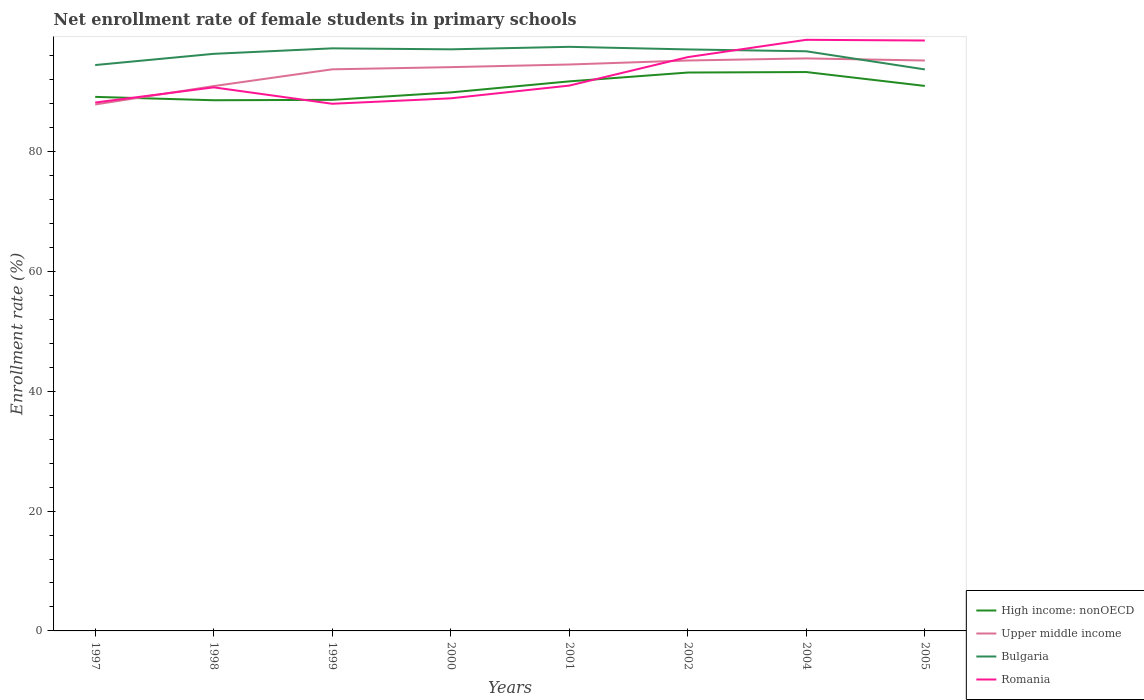Across all years, what is the maximum net enrollment rate of female students in primary schools in Romania?
Make the answer very short. 87.99. In which year was the net enrollment rate of female students in primary schools in Romania maximum?
Offer a very short reply. 1999. What is the total net enrollment rate of female students in primary schools in Upper middle income in the graph?
Provide a short and direct response. -0.67. What is the difference between the highest and the second highest net enrollment rate of female students in primary schools in Bulgaria?
Your answer should be compact. 3.77. What is the difference between the highest and the lowest net enrollment rate of female students in primary schools in Bulgaria?
Offer a terse response. 6. Is the net enrollment rate of female students in primary schools in Bulgaria strictly greater than the net enrollment rate of female students in primary schools in Upper middle income over the years?
Your answer should be very brief. No. What is the title of the graph?
Make the answer very short. Net enrollment rate of female students in primary schools. What is the label or title of the X-axis?
Provide a succinct answer. Years. What is the label or title of the Y-axis?
Provide a short and direct response. Enrollment rate (%). What is the Enrollment rate (%) of High income: nonOECD in 1997?
Your response must be concise. 89.15. What is the Enrollment rate (%) in Upper middle income in 1997?
Ensure brevity in your answer.  87.88. What is the Enrollment rate (%) in Bulgaria in 1997?
Provide a short and direct response. 94.46. What is the Enrollment rate (%) in Romania in 1997?
Offer a terse response. 88.2. What is the Enrollment rate (%) of High income: nonOECD in 1998?
Your answer should be very brief. 88.58. What is the Enrollment rate (%) of Upper middle income in 1998?
Give a very brief answer. 90.95. What is the Enrollment rate (%) in Bulgaria in 1998?
Make the answer very short. 96.33. What is the Enrollment rate (%) of Romania in 1998?
Your answer should be very brief. 90.73. What is the Enrollment rate (%) of High income: nonOECD in 1999?
Offer a terse response. 88.65. What is the Enrollment rate (%) in Upper middle income in 1999?
Provide a short and direct response. 93.74. What is the Enrollment rate (%) in Bulgaria in 1999?
Your answer should be very brief. 97.25. What is the Enrollment rate (%) of Romania in 1999?
Your answer should be compact. 87.99. What is the Enrollment rate (%) in High income: nonOECD in 2000?
Keep it short and to the point. 89.89. What is the Enrollment rate (%) in Upper middle income in 2000?
Your answer should be very brief. 94.11. What is the Enrollment rate (%) of Bulgaria in 2000?
Your answer should be compact. 97.08. What is the Enrollment rate (%) in Romania in 2000?
Make the answer very short. 88.9. What is the Enrollment rate (%) in High income: nonOECD in 2001?
Ensure brevity in your answer.  91.73. What is the Enrollment rate (%) in Upper middle income in 2001?
Offer a very short reply. 94.55. What is the Enrollment rate (%) in Bulgaria in 2001?
Your answer should be very brief. 97.5. What is the Enrollment rate (%) of Romania in 2001?
Your answer should be very brief. 91.03. What is the Enrollment rate (%) in High income: nonOECD in 2002?
Ensure brevity in your answer.  93.21. What is the Enrollment rate (%) of Upper middle income in 2002?
Ensure brevity in your answer.  95.22. What is the Enrollment rate (%) of Bulgaria in 2002?
Provide a succinct answer. 97.07. What is the Enrollment rate (%) in Romania in 2002?
Provide a short and direct response. 95.78. What is the Enrollment rate (%) in High income: nonOECD in 2004?
Your answer should be very brief. 93.29. What is the Enrollment rate (%) in Upper middle income in 2004?
Make the answer very short. 95.57. What is the Enrollment rate (%) in Bulgaria in 2004?
Make the answer very short. 96.76. What is the Enrollment rate (%) of Romania in 2004?
Offer a very short reply. 98.67. What is the Enrollment rate (%) in High income: nonOECD in 2005?
Give a very brief answer. 90.97. What is the Enrollment rate (%) of Upper middle income in 2005?
Ensure brevity in your answer.  95.22. What is the Enrollment rate (%) of Bulgaria in 2005?
Your answer should be very brief. 93.73. What is the Enrollment rate (%) in Romania in 2005?
Your answer should be compact. 98.55. Across all years, what is the maximum Enrollment rate (%) in High income: nonOECD?
Your answer should be very brief. 93.29. Across all years, what is the maximum Enrollment rate (%) of Upper middle income?
Your answer should be very brief. 95.57. Across all years, what is the maximum Enrollment rate (%) of Bulgaria?
Give a very brief answer. 97.5. Across all years, what is the maximum Enrollment rate (%) of Romania?
Keep it short and to the point. 98.67. Across all years, what is the minimum Enrollment rate (%) of High income: nonOECD?
Keep it short and to the point. 88.58. Across all years, what is the minimum Enrollment rate (%) in Upper middle income?
Provide a succinct answer. 87.88. Across all years, what is the minimum Enrollment rate (%) in Bulgaria?
Your answer should be very brief. 93.73. Across all years, what is the minimum Enrollment rate (%) of Romania?
Offer a terse response. 87.99. What is the total Enrollment rate (%) of High income: nonOECD in the graph?
Give a very brief answer. 725.48. What is the total Enrollment rate (%) of Upper middle income in the graph?
Your answer should be compact. 747.23. What is the total Enrollment rate (%) in Bulgaria in the graph?
Ensure brevity in your answer.  770.17. What is the total Enrollment rate (%) in Romania in the graph?
Offer a very short reply. 739.87. What is the difference between the Enrollment rate (%) of High income: nonOECD in 1997 and that in 1998?
Make the answer very short. 0.56. What is the difference between the Enrollment rate (%) in Upper middle income in 1997 and that in 1998?
Keep it short and to the point. -3.07. What is the difference between the Enrollment rate (%) in Bulgaria in 1997 and that in 1998?
Provide a succinct answer. -1.87. What is the difference between the Enrollment rate (%) in Romania in 1997 and that in 1998?
Provide a short and direct response. -2.53. What is the difference between the Enrollment rate (%) in High income: nonOECD in 1997 and that in 1999?
Offer a very short reply. 0.5. What is the difference between the Enrollment rate (%) of Upper middle income in 1997 and that in 1999?
Make the answer very short. -5.87. What is the difference between the Enrollment rate (%) in Bulgaria in 1997 and that in 1999?
Provide a short and direct response. -2.79. What is the difference between the Enrollment rate (%) of Romania in 1997 and that in 1999?
Provide a succinct answer. 0.21. What is the difference between the Enrollment rate (%) in High income: nonOECD in 1997 and that in 2000?
Offer a very short reply. -0.75. What is the difference between the Enrollment rate (%) of Upper middle income in 1997 and that in 2000?
Provide a succinct answer. -6.23. What is the difference between the Enrollment rate (%) in Bulgaria in 1997 and that in 2000?
Ensure brevity in your answer.  -2.62. What is the difference between the Enrollment rate (%) in Romania in 1997 and that in 2000?
Provide a short and direct response. -0.7. What is the difference between the Enrollment rate (%) of High income: nonOECD in 1997 and that in 2001?
Keep it short and to the point. -2.59. What is the difference between the Enrollment rate (%) of Upper middle income in 1997 and that in 2001?
Your response must be concise. -6.68. What is the difference between the Enrollment rate (%) of Bulgaria in 1997 and that in 2001?
Give a very brief answer. -3.04. What is the difference between the Enrollment rate (%) in Romania in 1997 and that in 2001?
Offer a very short reply. -2.83. What is the difference between the Enrollment rate (%) in High income: nonOECD in 1997 and that in 2002?
Ensure brevity in your answer.  -4.06. What is the difference between the Enrollment rate (%) in Upper middle income in 1997 and that in 2002?
Your answer should be very brief. -7.34. What is the difference between the Enrollment rate (%) in Bulgaria in 1997 and that in 2002?
Keep it short and to the point. -2.61. What is the difference between the Enrollment rate (%) of Romania in 1997 and that in 2002?
Your response must be concise. -7.58. What is the difference between the Enrollment rate (%) of High income: nonOECD in 1997 and that in 2004?
Make the answer very short. -4.14. What is the difference between the Enrollment rate (%) of Upper middle income in 1997 and that in 2004?
Provide a short and direct response. -7.69. What is the difference between the Enrollment rate (%) in Bulgaria in 1997 and that in 2004?
Give a very brief answer. -2.3. What is the difference between the Enrollment rate (%) of Romania in 1997 and that in 2004?
Your response must be concise. -10.47. What is the difference between the Enrollment rate (%) of High income: nonOECD in 1997 and that in 2005?
Your response must be concise. -1.83. What is the difference between the Enrollment rate (%) of Upper middle income in 1997 and that in 2005?
Offer a terse response. -7.34. What is the difference between the Enrollment rate (%) in Bulgaria in 1997 and that in 2005?
Provide a succinct answer. 0.73. What is the difference between the Enrollment rate (%) of Romania in 1997 and that in 2005?
Make the answer very short. -10.35. What is the difference between the Enrollment rate (%) of High income: nonOECD in 1998 and that in 1999?
Provide a succinct answer. -0.07. What is the difference between the Enrollment rate (%) in Upper middle income in 1998 and that in 1999?
Offer a very short reply. -2.8. What is the difference between the Enrollment rate (%) of Bulgaria in 1998 and that in 1999?
Ensure brevity in your answer.  -0.92. What is the difference between the Enrollment rate (%) of Romania in 1998 and that in 1999?
Your answer should be compact. 2.74. What is the difference between the Enrollment rate (%) of High income: nonOECD in 1998 and that in 2000?
Your response must be concise. -1.31. What is the difference between the Enrollment rate (%) of Upper middle income in 1998 and that in 2000?
Your answer should be compact. -3.16. What is the difference between the Enrollment rate (%) of Bulgaria in 1998 and that in 2000?
Keep it short and to the point. -0.75. What is the difference between the Enrollment rate (%) in Romania in 1998 and that in 2000?
Offer a terse response. 1.83. What is the difference between the Enrollment rate (%) in High income: nonOECD in 1998 and that in 2001?
Offer a very short reply. -3.15. What is the difference between the Enrollment rate (%) in Upper middle income in 1998 and that in 2001?
Your answer should be compact. -3.6. What is the difference between the Enrollment rate (%) of Bulgaria in 1998 and that in 2001?
Give a very brief answer. -1.17. What is the difference between the Enrollment rate (%) of Romania in 1998 and that in 2001?
Provide a short and direct response. -0.3. What is the difference between the Enrollment rate (%) of High income: nonOECD in 1998 and that in 2002?
Offer a terse response. -4.63. What is the difference between the Enrollment rate (%) in Upper middle income in 1998 and that in 2002?
Your answer should be very brief. -4.27. What is the difference between the Enrollment rate (%) of Bulgaria in 1998 and that in 2002?
Your answer should be very brief. -0.74. What is the difference between the Enrollment rate (%) of Romania in 1998 and that in 2002?
Give a very brief answer. -5.05. What is the difference between the Enrollment rate (%) of High income: nonOECD in 1998 and that in 2004?
Offer a very short reply. -4.71. What is the difference between the Enrollment rate (%) of Upper middle income in 1998 and that in 2004?
Your answer should be compact. -4.62. What is the difference between the Enrollment rate (%) of Bulgaria in 1998 and that in 2004?
Offer a very short reply. -0.42. What is the difference between the Enrollment rate (%) of Romania in 1998 and that in 2004?
Give a very brief answer. -7.94. What is the difference between the Enrollment rate (%) in High income: nonOECD in 1998 and that in 2005?
Offer a very short reply. -2.39. What is the difference between the Enrollment rate (%) in Upper middle income in 1998 and that in 2005?
Offer a very short reply. -4.27. What is the difference between the Enrollment rate (%) of Bulgaria in 1998 and that in 2005?
Provide a succinct answer. 2.6. What is the difference between the Enrollment rate (%) in Romania in 1998 and that in 2005?
Your response must be concise. -7.82. What is the difference between the Enrollment rate (%) in High income: nonOECD in 1999 and that in 2000?
Keep it short and to the point. -1.24. What is the difference between the Enrollment rate (%) in Upper middle income in 1999 and that in 2000?
Give a very brief answer. -0.37. What is the difference between the Enrollment rate (%) in Bulgaria in 1999 and that in 2000?
Provide a short and direct response. 0.16. What is the difference between the Enrollment rate (%) of Romania in 1999 and that in 2000?
Your answer should be compact. -0.91. What is the difference between the Enrollment rate (%) of High income: nonOECD in 1999 and that in 2001?
Provide a short and direct response. -3.08. What is the difference between the Enrollment rate (%) in Upper middle income in 1999 and that in 2001?
Offer a very short reply. -0.81. What is the difference between the Enrollment rate (%) in Bulgaria in 1999 and that in 2001?
Keep it short and to the point. -0.25. What is the difference between the Enrollment rate (%) in Romania in 1999 and that in 2001?
Provide a short and direct response. -3.04. What is the difference between the Enrollment rate (%) of High income: nonOECD in 1999 and that in 2002?
Provide a succinct answer. -4.56. What is the difference between the Enrollment rate (%) of Upper middle income in 1999 and that in 2002?
Your answer should be very brief. -1.47. What is the difference between the Enrollment rate (%) of Bulgaria in 1999 and that in 2002?
Give a very brief answer. 0.18. What is the difference between the Enrollment rate (%) in Romania in 1999 and that in 2002?
Make the answer very short. -7.79. What is the difference between the Enrollment rate (%) in High income: nonOECD in 1999 and that in 2004?
Make the answer very short. -4.64. What is the difference between the Enrollment rate (%) in Upper middle income in 1999 and that in 2004?
Ensure brevity in your answer.  -1.82. What is the difference between the Enrollment rate (%) in Bulgaria in 1999 and that in 2004?
Your response must be concise. 0.49. What is the difference between the Enrollment rate (%) in Romania in 1999 and that in 2004?
Keep it short and to the point. -10.68. What is the difference between the Enrollment rate (%) of High income: nonOECD in 1999 and that in 2005?
Provide a succinct answer. -2.32. What is the difference between the Enrollment rate (%) of Upper middle income in 1999 and that in 2005?
Your answer should be compact. -1.47. What is the difference between the Enrollment rate (%) in Bulgaria in 1999 and that in 2005?
Provide a succinct answer. 3.52. What is the difference between the Enrollment rate (%) of Romania in 1999 and that in 2005?
Give a very brief answer. -10.56. What is the difference between the Enrollment rate (%) in High income: nonOECD in 2000 and that in 2001?
Offer a terse response. -1.84. What is the difference between the Enrollment rate (%) of Upper middle income in 2000 and that in 2001?
Offer a very short reply. -0.44. What is the difference between the Enrollment rate (%) in Bulgaria in 2000 and that in 2001?
Your response must be concise. -0.42. What is the difference between the Enrollment rate (%) in Romania in 2000 and that in 2001?
Your answer should be compact. -2.13. What is the difference between the Enrollment rate (%) in High income: nonOECD in 2000 and that in 2002?
Your response must be concise. -3.32. What is the difference between the Enrollment rate (%) in Upper middle income in 2000 and that in 2002?
Provide a short and direct response. -1.11. What is the difference between the Enrollment rate (%) in Bulgaria in 2000 and that in 2002?
Provide a short and direct response. 0.02. What is the difference between the Enrollment rate (%) of Romania in 2000 and that in 2002?
Offer a very short reply. -6.88. What is the difference between the Enrollment rate (%) of High income: nonOECD in 2000 and that in 2004?
Ensure brevity in your answer.  -3.4. What is the difference between the Enrollment rate (%) of Upper middle income in 2000 and that in 2004?
Provide a succinct answer. -1.46. What is the difference between the Enrollment rate (%) in Bulgaria in 2000 and that in 2004?
Make the answer very short. 0.33. What is the difference between the Enrollment rate (%) in Romania in 2000 and that in 2004?
Ensure brevity in your answer.  -9.77. What is the difference between the Enrollment rate (%) of High income: nonOECD in 2000 and that in 2005?
Provide a short and direct response. -1.08. What is the difference between the Enrollment rate (%) of Upper middle income in 2000 and that in 2005?
Your answer should be compact. -1.11. What is the difference between the Enrollment rate (%) in Bulgaria in 2000 and that in 2005?
Your answer should be compact. 3.35. What is the difference between the Enrollment rate (%) of Romania in 2000 and that in 2005?
Offer a terse response. -9.65. What is the difference between the Enrollment rate (%) of High income: nonOECD in 2001 and that in 2002?
Give a very brief answer. -1.47. What is the difference between the Enrollment rate (%) in Upper middle income in 2001 and that in 2002?
Offer a very short reply. -0.67. What is the difference between the Enrollment rate (%) of Bulgaria in 2001 and that in 2002?
Provide a succinct answer. 0.43. What is the difference between the Enrollment rate (%) in Romania in 2001 and that in 2002?
Give a very brief answer. -4.75. What is the difference between the Enrollment rate (%) of High income: nonOECD in 2001 and that in 2004?
Offer a terse response. -1.55. What is the difference between the Enrollment rate (%) in Upper middle income in 2001 and that in 2004?
Provide a succinct answer. -1.02. What is the difference between the Enrollment rate (%) of Bulgaria in 2001 and that in 2004?
Make the answer very short. 0.74. What is the difference between the Enrollment rate (%) in Romania in 2001 and that in 2004?
Offer a terse response. -7.64. What is the difference between the Enrollment rate (%) in High income: nonOECD in 2001 and that in 2005?
Provide a short and direct response. 0.76. What is the difference between the Enrollment rate (%) in Upper middle income in 2001 and that in 2005?
Your response must be concise. -0.67. What is the difference between the Enrollment rate (%) in Bulgaria in 2001 and that in 2005?
Your answer should be very brief. 3.77. What is the difference between the Enrollment rate (%) of Romania in 2001 and that in 2005?
Offer a very short reply. -7.52. What is the difference between the Enrollment rate (%) in High income: nonOECD in 2002 and that in 2004?
Offer a very short reply. -0.08. What is the difference between the Enrollment rate (%) in Upper middle income in 2002 and that in 2004?
Offer a very short reply. -0.35. What is the difference between the Enrollment rate (%) in Bulgaria in 2002 and that in 2004?
Keep it short and to the point. 0.31. What is the difference between the Enrollment rate (%) in Romania in 2002 and that in 2004?
Keep it short and to the point. -2.89. What is the difference between the Enrollment rate (%) in High income: nonOECD in 2002 and that in 2005?
Your answer should be compact. 2.24. What is the difference between the Enrollment rate (%) in Upper middle income in 2002 and that in 2005?
Your answer should be very brief. -0. What is the difference between the Enrollment rate (%) in Bulgaria in 2002 and that in 2005?
Offer a terse response. 3.34. What is the difference between the Enrollment rate (%) of Romania in 2002 and that in 2005?
Give a very brief answer. -2.77. What is the difference between the Enrollment rate (%) of High income: nonOECD in 2004 and that in 2005?
Your answer should be very brief. 2.32. What is the difference between the Enrollment rate (%) of Upper middle income in 2004 and that in 2005?
Keep it short and to the point. 0.35. What is the difference between the Enrollment rate (%) of Bulgaria in 2004 and that in 2005?
Keep it short and to the point. 3.03. What is the difference between the Enrollment rate (%) of Romania in 2004 and that in 2005?
Make the answer very short. 0.12. What is the difference between the Enrollment rate (%) in High income: nonOECD in 1997 and the Enrollment rate (%) in Upper middle income in 1998?
Provide a short and direct response. -1.8. What is the difference between the Enrollment rate (%) of High income: nonOECD in 1997 and the Enrollment rate (%) of Bulgaria in 1998?
Your response must be concise. -7.18. What is the difference between the Enrollment rate (%) in High income: nonOECD in 1997 and the Enrollment rate (%) in Romania in 1998?
Offer a very short reply. -1.59. What is the difference between the Enrollment rate (%) in Upper middle income in 1997 and the Enrollment rate (%) in Bulgaria in 1998?
Your response must be concise. -8.46. What is the difference between the Enrollment rate (%) of Upper middle income in 1997 and the Enrollment rate (%) of Romania in 1998?
Your answer should be compact. -2.86. What is the difference between the Enrollment rate (%) in Bulgaria in 1997 and the Enrollment rate (%) in Romania in 1998?
Give a very brief answer. 3.72. What is the difference between the Enrollment rate (%) of High income: nonOECD in 1997 and the Enrollment rate (%) of Upper middle income in 1999?
Make the answer very short. -4.6. What is the difference between the Enrollment rate (%) in High income: nonOECD in 1997 and the Enrollment rate (%) in Bulgaria in 1999?
Ensure brevity in your answer.  -8.1. What is the difference between the Enrollment rate (%) of High income: nonOECD in 1997 and the Enrollment rate (%) of Romania in 1999?
Offer a terse response. 1.15. What is the difference between the Enrollment rate (%) of Upper middle income in 1997 and the Enrollment rate (%) of Bulgaria in 1999?
Offer a very short reply. -9.37. What is the difference between the Enrollment rate (%) in Upper middle income in 1997 and the Enrollment rate (%) in Romania in 1999?
Your answer should be compact. -0.12. What is the difference between the Enrollment rate (%) in Bulgaria in 1997 and the Enrollment rate (%) in Romania in 1999?
Give a very brief answer. 6.46. What is the difference between the Enrollment rate (%) in High income: nonOECD in 1997 and the Enrollment rate (%) in Upper middle income in 2000?
Make the answer very short. -4.96. What is the difference between the Enrollment rate (%) in High income: nonOECD in 1997 and the Enrollment rate (%) in Bulgaria in 2000?
Offer a very short reply. -7.94. What is the difference between the Enrollment rate (%) in High income: nonOECD in 1997 and the Enrollment rate (%) in Romania in 2000?
Keep it short and to the point. 0.24. What is the difference between the Enrollment rate (%) of Upper middle income in 1997 and the Enrollment rate (%) of Bulgaria in 2000?
Your response must be concise. -9.21. What is the difference between the Enrollment rate (%) in Upper middle income in 1997 and the Enrollment rate (%) in Romania in 2000?
Provide a short and direct response. -1.03. What is the difference between the Enrollment rate (%) of Bulgaria in 1997 and the Enrollment rate (%) of Romania in 2000?
Provide a succinct answer. 5.56. What is the difference between the Enrollment rate (%) in High income: nonOECD in 1997 and the Enrollment rate (%) in Upper middle income in 2001?
Give a very brief answer. -5.4. What is the difference between the Enrollment rate (%) of High income: nonOECD in 1997 and the Enrollment rate (%) of Bulgaria in 2001?
Offer a very short reply. -8.35. What is the difference between the Enrollment rate (%) of High income: nonOECD in 1997 and the Enrollment rate (%) of Romania in 2001?
Your answer should be very brief. -1.88. What is the difference between the Enrollment rate (%) of Upper middle income in 1997 and the Enrollment rate (%) of Bulgaria in 2001?
Ensure brevity in your answer.  -9.62. What is the difference between the Enrollment rate (%) of Upper middle income in 1997 and the Enrollment rate (%) of Romania in 2001?
Your answer should be compact. -3.16. What is the difference between the Enrollment rate (%) in Bulgaria in 1997 and the Enrollment rate (%) in Romania in 2001?
Offer a terse response. 3.43. What is the difference between the Enrollment rate (%) in High income: nonOECD in 1997 and the Enrollment rate (%) in Upper middle income in 2002?
Give a very brief answer. -6.07. What is the difference between the Enrollment rate (%) in High income: nonOECD in 1997 and the Enrollment rate (%) in Bulgaria in 2002?
Make the answer very short. -7.92. What is the difference between the Enrollment rate (%) in High income: nonOECD in 1997 and the Enrollment rate (%) in Romania in 2002?
Your answer should be very brief. -6.64. What is the difference between the Enrollment rate (%) of Upper middle income in 1997 and the Enrollment rate (%) of Bulgaria in 2002?
Keep it short and to the point. -9.19. What is the difference between the Enrollment rate (%) of Upper middle income in 1997 and the Enrollment rate (%) of Romania in 2002?
Ensure brevity in your answer.  -7.91. What is the difference between the Enrollment rate (%) of Bulgaria in 1997 and the Enrollment rate (%) of Romania in 2002?
Your answer should be very brief. -1.32. What is the difference between the Enrollment rate (%) of High income: nonOECD in 1997 and the Enrollment rate (%) of Upper middle income in 2004?
Ensure brevity in your answer.  -6.42. What is the difference between the Enrollment rate (%) in High income: nonOECD in 1997 and the Enrollment rate (%) in Bulgaria in 2004?
Your response must be concise. -7.61. What is the difference between the Enrollment rate (%) of High income: nonOECD in 1997 and the Enrollment rate (%) of Romania in 2004?
Your answer should be very brief. -9.52. What is the difference between the Enrollment rate (%) of Upper middle income in 1997 and the Enrollment rate (%) of Bulgaria in 2004?
Offer a very short reply. -8.88. What is the difference between the Enrollment rate (%) of Upper middle income in 1997 and the Enrollment rate (%) of Romania in 2004?
Keep it short and to the point. -10.8. What is the difference between the Enrollment rate (%) in Bulgaria in 1997 and the Enrollment rate (%) in Romania in 2004?
Offer a very short reply. -4.21. What is the difference between the Enrollment rate (%) in High income: nonOECD in 1997 and the Enrollment rate (%) in Upper middle income in 2005?
Your answer should be very brief. -6.07. What is the difference between the Enrollment rate (%) of High income: nonOECD in 1997 and the Enrollment rate (%) of Bulgaria in 2005?
Make the answer very short. -4.58. What is the difference between the Enrollment rate (%) of High income: nonOECD in 1997 and the Enrollment rate (%) of Romania in 2005?
Offer a very short reply. -9.41. What is the difference between the Enrollment rate (%) of Upper middle income in 1997 and the Enrollment rate (%) of Bulgaria in 2005?
Your answer should be compact. -5.85. What is the difference between the Enrollment rate (%) in Upper middle income in 1997 and the Enrollment rate (%) in Romania in 2005?
Give a very brief answer. -10.68. What is the difference between the Enrollment rate (%) in Bulgaria in 1997 and the Enrollment rate (%) in Romania in 2005?
Keep it short and to the point. -4.1. What is the difference between the Enrollment rate (%) in High income: nonOECD in 1998 and the Enrollment rate (%) in Upper middle income in 1999?
Your response must be concise. -5.16. What is the difference between the Enrollment rate (%) of High income: nonOECD in 1998 and the Enrollment rate (%) of Bulgaria in 1999?
Keep it short and to the point. -8.66. What is the difference between the Enrollment rate (%) of High income: nonOECD in 1998 and the Enrollment rate (%) of Romania in 1999?
Make the answer very short. 0.59. What is the difference between the Enrollment rate (%) of Upper middle income in 1998 and the Enrollment rate (%) of Bulgaria in 1999?
Make the answer very short. -6.3. What is the difference between the Enrollment rate (%) of Upper middle income in 1998 and the Enrollment rate (%) of Romania in 1999?
Offer a terse response. 2.95. What is the difference between the Enrollment rate (%) of Bulgaria in 1998 and the Enrollment rate (%) of Romania in 1999?
Make the answer very short. 8.34. What is the difference between the Enrollment rate (%) of High income: nonOECD in 1998 and the Enrollment rate (%) of Upper middle income in 2000?
Your response must be concise. -5.53. What is the difference between the Enrollment rate (%) of High income: nonOECD in 1998 and the Enrollment rate (%) of Bulgaria in 2000?
Your answer should be very brief. -8.5. What is the difference between the Enrollment rate (%) of High income: nonOECD in 1998 and the Enrollment rate (%) of Romania in 2000?
Ensure brevity in your answer.  -0.32. What is the difference between the Enrollment rate (%) of Upper middle income in 1998 and the Enrollment rate (%) of Bulgaria in 2000?
Offer a very short reply. -6.14. What is the difference between the Enrollment rate (%) of Upper middle income in 1998 and the Enrollment rate (%) of Romania in 2000?
Give a very brief answer. 2.04. What is the difference between the Enrollment rate (%) of Bulgaria in 1998 and the Enrollment rate (%) of Romania in 2000?
Offer a terse response. 7.43. What is the difference between the Enrollment rate (%) of High income: nonOECD in 1998 and the Enrollment rate (%) of Upper middle income in 2001?
Give a very brief answer. -5.97. What is the difference between the Enrollment rate (%) in High income: nonOECD in 1998 and the Enrollment rate (%) in Bulgaria in 2001?
Ensure brevity in your answer.  -8.92. What is the difference between the Enrollment rate (%) in High income: nonOECD in 1998 and the Enrollment rate (%) in Romania in 2001?
Offer a very short reply. -2.45. What is the difference between the Enrollment rate (%) in Upper middle income in 1998 and the Enrollment rate (%) in Bulgaria in 2001?
Your response must be concise. -6.55. What is the difference between the Enrollment rate (%) of Upper middle income in 1998 and the Enrollment rate (%) of Romania in 2001?
Offer a very short reply. -0.09. What is the difference between the Enrollment rate (%) in Bulgaria in 1998 and the Enrollment rate (%) in Romania in 2001?
Give a very brief answer. 5.3. What is the difference between the Enrollment rate (%) of High income: nonOECD in 1998 and the Enrollment rate (%) of Upper middle income in 2002?
Keep it short and to the point. -6.63. What is the difference between the Enrollment rate (%) of High income: nonOECD in 1998 and the Enrollment rate (%) of Bulgaria in 2002?
Provide a succinct answer. -8.48. What is the difference between the Enrollment rate (%) of High income: nonOECD in 1998 and the Enrollment rate (%) of Romania in 2002?
Provide a short and direct response. -7.2. What is the difference between the Enrollment rate (%) in Upper middle income in 1998 and the Enrollment rate (%) in Bulgaria in 2002?
Your response must be concise. -6.12. What is the difference between the Enrollment rate (%) of Upper middle income in 1998 and the Enrollment rate (%) of Romania in 2002?
Ensure brevity in your answer.  -4.84. What is the difference between the Enrollment rate (%) in Bulgaria in 1998 and the Enrollment rate (%) in Romania in 2002?
Keep it short and to the point. 0.55. What is the difference between the Enrollment rate (%) of High income: nonOECD in 1998 and the Enrollment rate (%) of Upper middle income in 2004?
Your answer should be very brief. -6.98. What is the difference between the Enrollment rate (%) of High income: nonOECD in 1998 and the Enrollment rate (%) of Bulgaria in 2004?
Keep it short and to the point. -8.17. What is the difference between the Enrollment rate (%) in High income: nonOECD in 1998 and the Enrollment rate (%) in Romania in 2004?
Make the answer very short. -10.09. What is the difference between the Enrollment rate (%) of Upper middle income in 1998 and the Enrollment rate (%) of Bulgaria in 2004?
Make the answer very short. -5.81. What is the difference between the Enrollment rate (%) in Upper middle income in 1998 and the Enrollment rate (%) in Romania in 2004?
Offer a very short reply. -7.73. What is the difference between the Enrollment rate (%) in Bulgaria in 1998 and the Enrollment rate (%) in Romania in 2004?
Make the answer very short. -2.34. What is the difference between the Enrollment rate (%) in High income: nonOECD in 1998 and the Enrollment rate (%) in Upper middle income in 2005?
Provide a short and direct response. -6.64. What is the difference between the Enrollment rate (%) in High income: nonOECD in 1998 and the Enrollment rate (%) in Bulgaria in 2005?
Give a very brief answer. -5.15. What is the difference between the Enrollment rate (%) in High income: nonOECD in 1998 and the Enrollment rate (%) in Romania in 2005?
Your response must be concise. -9.97. What is the difference between the Enrollment rate (%) of Upper middle income in 1998 and the Enrollment rate (%) of Bulgaria in 2005?
Ensure brevity in your answer.  -2.78. What is the difference between the Enrollment rate (%) in Upper middle income in 1998 and the Enrollment rate (%) in Romania in 2005?
Provide a short and direct response. -7.61. What is the difference between the Enrollment rate (%) in Bulgaria in 1998 and the Enrollment rate (%) in Romania in 2005?
Make the answer very short. -2.22. What is the difference between the Enrollment rate (%) in High income: nonOECD in 1999 and the Enrollment rate (%) in Upper middle income in 2000?
Provide a short and direct response. -5.46. What is the difference between the Enrollment rate (%) of High income: nonOECD in 1999 and the Enrollment rate (%) of Bulgaria in 2000?
Provide a short and direct response. -8.43. What is the difference between the Enrollment rate (%) in High income: nonOECD in 1999 and the Enrollment rate (%) in Romania in 2000?
Ensure brevity in your answer.  -0.25. What is the difference between the Enrollment rate (%) in Upper middle income in 1999 and the Enrollment rate (%) in Bulgaria in 2000?
Keep it short and to the point. -3.34. What is the difference between the Enrollment rate (%) in Upper middle income in 1999 and the Enrollment rate (%) in Romania in 2000?
Provide a succinct answer. 4.84. What is the difference between the Enrollment rate (%) in Bulgaria in 1999 and the Enrollment rate (%) in Romania in 2000?
Provide a short and direct response. 8.34. What is the difference between the Enrollment rate (%) of High income: nonOECD in 1999 and the Enrollment rate (%) of Upper middle income in 2001?
Keep it short and to the point. -5.9. What is the difference between the Enrollment rate (%) of High income: nonOECD in 1999 and the Enrollment rate (%) of Bulgaria in 2001?
Offer a terse response. -8.85. What is the difference between the Enrollment rate (%) of High income: nonOECD in 1999 and the Enrollment rate (%) of Romania in 2001?
Provide a short and direct response. -2.38. What is the difference between the Enrollment rate (%) in Upper middle income in 1999 and the Enrollment rate (%) in Bulgaria in 2001?
Offer a very short reply. -3.75. What is the difference between the Enrollment rate (%) in Upper middle income in 1999 and the Enrollment rate (%) in Romania in 2001?
Your answer should be very brief. 2.71. What is the difference between the Enrollment rate (%) of Bulgaria in 1999 and the Enrollment rate (%) of Romania in 2001?
Provide a short and direct response. 6.22. What is the difference between the Enrollment rate (%) in High income: nonOECD in 1999 and the Enrollment rate (%) in Upper middle income in 2002?
Your answer should be compact. -6.57. What is the difference between the Enrollment rate (%) in High income: nonOECD in 1999 and the Enrollment rate (%) in Bulgaria in 2002?
Your response must be concise. -8.42. What is the difference between the Enrollment rate (%) of High income: nonOECD in 1999 and the Enrollment rate (%) of Romania in 2002?
Your response must be concise. -7.13. What is the difference between the Enrollment rate (%) in Upper middle income in 1999 and the Enrollment rate (%) in Bulgaria in 2002?
Your answer should be very brief. -3.32. What is the difference between the Enrollment rate (%) in Upper middle income in 1999 and the Enrollment rate (%) in Romania in 2002?
Provide a short and direct response. -2.04. What is the difference between the Enrollment rate (%) in Bulgaria in 1999 and the Enrollment rate (%) in Romania in 2002?
Make the answer very short. 1.46. What is the difference between the Enrollment rate (%) of High income: nonOECD in 1999 and the Enrollment rate (%) of Upper middle income in 2004?
Your response must be concise. -6.92. What is the difference between the Enrollment rate (%) in High income: nonOECD in 1999 and the Enrollment rate (%) in Bulgaria in 2004?
Offer a very short reply. -8.1. What is the difference between the Enrollment rate (%) in High income: nonOECD in 1999 and the Enrollment rate (%) in Romania in 2004?
Give a very brief answer. -10.02. What is the difference between the Enrollment rate (%) of Upper middle income in 1999 and the Enrollment rate (%) of Bulgaria in 2004?
Your answer should be compact. -3.01. What is the difference between the Enrollment rate (%) in Upper middle income in 1999 and the Enrollment rate (%) in Romania in 2004?
Provide a succinct answer. -4.93. What is the difference between the Enrollment rate (%) in Bulgaria in 1999 and the Enrollment rate (%) in Romania in 2004?
Offer a very short reply. -1.42. What is the difference between the Enrollment rate (%) in High income: nonOECD in 1999 and the Enrollment rate (%) in Upper middle income in 2005?
Give a very brief answer. -6.57. What is the difference between the Enrollment rate (%) in High income: nonOECD in 1999 and the Enrollment rate (%) in Bulgaria in 2005?
Ensure brevity in your answer.  -5.08. What is the difference between the Enrollment rate (%) in High income: nonOECD in 1999 and the Enrollment rate (%) in Romania in 2005?
Ensure brevity in your answer.  -9.9. What is the difference between the Enrollment rate (%) in Upper middle income in 1999 and the Enrollment rate (%) in Bulgaria in 2005?
Your answer should be very brief. 0.02. What is the difference between the Enrollment rate (%) of Upper middle income in 1999 and the Enrollment rate (%) of Romania in 2005?
Offer a terse response. -4.81. What is the difference between the Enrollment rate (%) of Bulgaria in 1999 and the Enrollment rate (%) of Romania in 2005?
Your answer should be very brief. -1.31. What is the difference between the Enrollment rate (%) in High income: nonOECD in 2000 and the Enrollment rate (%) in Upper middle income in 2001?
Ensure brevity in your answer.  -4.66. What is the difference between the Enrollment rate (%) of High income: nonOECD in 2000 and the Enrollment rate (%) of Bulgaria in 2001?
Give a very brief answer. -7.61. What is the difference between the Enrollment rate (%) in High income: nonOECD in 2000 and the Enrollment rate (%) in Romania in 2001?
Give a very brief answer. -1.14. What is the difference between the Enrollment rate (%) in Upper middle income in 2000 and the Enrollment rate (%) in Bulgaria in 2001?
Provide a succinct answer. -3.39. What is the difference between the Enrollment rate (%) in Upper middle income in 2000 and the Enrollment rate (%) in Romania in 2001?
Provide a short and direct response. 3.08. What is the difference between the Enrollment rate (%) of Bulgaria in 2000 and the Enrollment rate (%) of Romania in 2001?
Provide a short and direct response. 6.05. What is the difference between the Enrollment rate (%) of High income: nonOECD in 2000 and the Enrollment rate (%) of Upper middle income in 2002?
Keep it short and to the point. -5.32. What is the difference between the Enrollment rate (%) of High income: nonOECD in 2000 and the Enrollment rate (%) of Bulgaria in 2002?
Ensure brevity in your answer.  -7.18. What is the difference between the Enrollment rate (%) in High income: nonOECD in 2000 and the Enrollment rate (%) in Romania in 2002?
Your answer should be very brief. -5.89. What is the difference between the Enrollment rate (%) in Upper middle income in 2000 and the Enrollment rate (%) in Bulgaria in 2002?
Ensure brevity in your answer.  -2.96. What is the difference between the Enrollment rate (%) of Upper middle income in 2000 and the Enrollment rate (%) of Romania in 2002?
Offer a very short reply. -1.67. What is the difference between the Enrollment rate (%) of Bulgaria in 2000 and the Enrollment rate (%) of Romania in 2002?
Make the answer very short. 1.3. What is the difference between the Enrollment rate (%) in High income: nonOECD in 2000 and the Enrollment rate (%) in Upper middle income in 2004?
Make the answer very short. -5.67. What is the difference between the Enrollment rate (%) of High income: nonOECD in 2000 and the Enrollment rate (%) of Bulgaria in 2004?
Give a very brief answer. -6.86. What is the difference between the Enrollment rate (%) in High income: nonOECD in 2000 and the Enrollment rate (%) in Romania in 2004?
Make the answer very short. -8.78. What is the difference between the Enrollment rate (%) of Upper middle income in 2000 and the Enrollment rate (%) of Bulgaria in 2004?
Offer a terse response. -2.65. What is the difference between the Enrollment rate (%) in Upper middle income in 2000 and the Enrollment rate (%) in Romania in 2004?
Your response must be concise. -4.56. What is the difference between the Enrollment rate (%) in Bulgaria in 2000 and the Enrollment rate (%) in Romania in 2004?
Provide a succinct answer. -1.59. What is the difference between the Enrollment rate (%) of High income: nonOECD in 2000 and the Enrollment rate (%) of Upper middle income in 2005?
Make the answer very short. -5.33. What is the difference between the Enrollment rate (%) in High income: nonOECD in 2000 and the Enrollment rate (%) in Bulgaria in 2005?
Your response must be concise. -3.84. What is the difference between the Enrollment rate (%) of High income: nonOECD in 2000 and the Enrollment rate (%) of Romania in 2005?
Ensure brevity in your answer.  -8.66. What is the difference between the Enrollment rate (%) in Upper middle income in 2000 and the Enrollment rate (%) in Bulgaria in 2005?
Your answer should be compact. 0.38. What is the difference between the Enrollment rate (%) in Upper middle income in 2000 and the Enrollment rate (%) in Romania in 2005?
Ensure brevity in your answer.  -4.44. What is the difference between the Enrollment rate (%) of Bulgaria in 2000 and the Enrollment rate (%) of Romania in 2005?
Make the answer very short. -1.47. What is the difference between the Enrollment rate (%) of High income: nonOECD in 2001 and the Enrollment rate (%) of Upper middle income in 2002?
Provide a short and direct response. -3.48. What is the difference between the Enrollment rate (%) of High income: nonOECD in 2001 and the Enrollment rate (%) of Bulgaria in 2002?
Your response must be concise. -5.33. What is the difference between the Enrollment rate (%) of High income: nonOECD in 2001 and the Enrollment rate (%) of Romania in 2002?
Give a very brief answer. -4.05. What is the difference between the Enrollment rate (%) in Upper middle income in 2001 and the Enrollment rate (%) in Bulgaria in 2002?
Your response must be concise. -2.52. What is the difference between the Enrollment rate (%) in Upper middle income in 2001 and the Enrollment rate (%) in Romania in 2002?
Provide a short and direct response. -1.23. What is the difference between the Enrollment rate (%) of Bulgaria in 2001 and the Enrollment rate (%) of Romania in 2002?
Provide a succinct answer. 1.72. What is the difference between the Enrollment rate (%) in High income: nonOECD in 2001 and the Enrollment rate (%) in Upper middle income in 2004?
Give a very brief answer. -3.83. What is the difference between the Enrollment rate (%) of High income: nonOECD in 2001 and the Enrollment rate (%) of Bulgaria in 2004?
Offer a very short reply. -5.02. What is the difference between the Enrollment rate (%) in High income: nonOECD in 2001 and the Enrollment rate (%) in Romania in 2004?
Your answer should be compact. -6.94. What is the difference between the Enrollment rate (%) of Upper middle income in 2001 and the Enrollment rate (%) of Bulgaria in 2004?
Your answer should be very brief. -2.21. What is the difference between the Enrollment rate (%) of Upper middle income in 2001 and the Enrollment rate (%) of Romania in 2004?
Ensure brevity in your answer.  -4.12. What is the difference between the Enrollment rate (%) in Bulgaria in 2001 and the Enrollment rate (%) in Romania in 2004?
Your answer should be very brief. -1.17. What is the difference between the Enrollment rate (%) of High income: nonOECD in 2001 and the Enrollment rate (%) of Upper middle income in 2005?
Offer a very short reply. -3.48. What is the difference between the Enrollment rate (%) in High income: nonOECD in 2001 and the Enrollment rate (%) in Bulgaria in 2005?
Ensure brevity in your answer.  -1.99. What is the difference between the Enrollment rate (%) in High income: nonOECD in 2001 and the Enrollment rate (%) in Romania in 2005?
Keep it short and to the point. -6.82. What is the difference between the Enrollment rate (%) of Upper middle income in 2001 and the Enrollment rate (%) of Bulgaria in 2005?
Your answer should be very brief. 0.82. What is the difference between the Enrollment rate (%) in Upper middle income in 2001 and the Enrollment rate (%) in Romania in 2005?
Offer a terse response. -4. What is the difference between the Enrollment rate (%) in Bulgaria in 2001 and the Enrollment rate (%) in Romania in 2005?
Your answer should be compact. -1.06. What is the difference between the Enrollment rate (%) of High income: nonOECD in 2002 and the Enrollment rate (%) of Upper middle income in 2004?
Give a very brief answer. -2.36. What is the difference between the Enrollment rate (%) in High income: nonOECD in 2002 and the Enrollment rate (%) in Bulgaria in 2004?
Ensure brevity in your answer.  -3.55. What is the difference between the Enrollment rate (%) of High income: nonOECD in 2002 and the Enrollment rate (%) of Romania in 2004?
Your answer should be very brief. -5.46. What is the difference between the Enrollment rate (%) in Upper middle income in 2002 and the Enrollment rate (%) in Bulgaria in 2004?
Make the answer very short. -1.54. What is the difference between the Enrollment rate (%) in Upper middle income in 2002 and the Enrollment rate (%) in Romania in 2004?
Keep it short and to the point. -3.45. What is the difference between the Enrollment rate (%) in Bulgaria in 2002 and the Enrollment rate (%) in Romania in 2004?
Provide a short and direct response. -1.6. What is the difference between the Enrollment rate (%) in High income: nonOECD in 2002 and the Enrollment rate (%) in Upper middle income in 2005?
Your response must be concise. -2.01. What is the difference between the Enrollment rate (%) in High income: nonOECD in 2002 and the Enrollment rate (%) in Bulgaria in 2005?
Your answer should be compact. -0.52. What is the difference between the Enrollment rate (%) in High income: nonOECD in 2002 and the Enrollment rate (%) in Romania in 2005?
Give a very brief answer. -5.35. What is the difference between the Enrollment rate (%) in Upper middle income in 2002 and the Enrollment rate (%) in Bulgaria in 2005?
Your answer should be very brief. 1.49. What is the difference between the Enrollment rate (%) of Upper middle income in 2002 and the Enrollment rate (%) of Romania in 2005?
Offer a very short reply. -3.34. What is the difference between the Enrollment rate (%) in Bulgaria in 2002 and the Enrollment rate (%) in Romania in 2005?
Offer a terse response. -1.49. What is the difference between the Enrollment rate (%) in High income: nonOECD in 2004 and the Enrollment rate (%) in Upper middle income in 2005?
Your response must be concise. -1.93. What is the difference between the Enrollment rate (%) in High income: nonOECD in 2004 and the Enrollment rate (%) in Bulgaria in 2005?
Give a very brief answer. -0.44. What is the difference between the Enrollment rate (%) of High income: nonOECD in 2004 and the Enrollment rate (%) of Romania in 2005?
Offer a very short reply. -5.27. What is the difference between the Enrollment rate (%) in Upper middle income in 2004 and the Enrollment rate (%) in Bulgaria in 2005?
Offer a very short reply. 1.84. What is the difference between the Enrollment rate (%) of Upper middle income in 2004 and the Enrollment rate (%) of Romania in 2005?
Give a very brief answer. -2.99. What is the difference between the Enrollment rate (%) in Bulgaria in 2004 and the Enrollment rate (%) in Romania in 2005?
Provide a succinct answer. -1.8. What is the average Enrollment rate (%) in High income: nonOECD per year?
Provide a succinct answer. 90.68. What is the average Enrollment rate (%) in Upper middle income per year?
Offer a very short reply. 93.4. What is the average Enrollment rate (%) in Bulgaria per year?
Your response must be concise. 96.27. What is the average Enrollment rate (%) in Romania per year?
Keep it short and to the point. 92.48. In the year 1997, what is the difference between the Enrollment rate (%) in High income: nonOECD and Enrollment rate (%) in Upper middle income?
Your answer should be very brief. 1.27. In the year 1997, what is the difference between the Enrollment rate (%) in High income: nonOECD and Enrollment rate (%) in Bulgaria?
Offer a very short reply. -5.31. In the year 1997, what is the difference between the Enrollment rate (%) in High income: nonOECD and Enrollment rate (%) in Romania?
Your answer should be very brief. 0.95. In the year 1997, what is the difference between the Enrollment rate (%) in Upper middle income and Enrollment rate (%) in Bulgaria?
Provide a succinct answer. -6.58. In the year 1997, what is the difference between the Enrollment rate (%) of Upper middle income and Enrollment rate (%) of Romania?
Give a very brief answer. -0.32. In the year 1997, what is the difference between the Enrollment rate (%) of Bulgaria and Enrollment rate (%) of Romania?
Provide a succinct answer. 6.26. In the year 1998, what is the difference between the Enrollment rate (%) of High income: nonOECD and Enrollment rate (%) of Upper middle income?
Make the answer very short. -2.36. In the year 1998, what is the difference between the Enrollment rate (%) of High income: nonOECD and Enrollment rate (%) of Bulgaria?
Provide a succinct answer. -7.75. In the year 1998, what is the difference between the Enrollment rate (%) of High income: nonOECD and Enrollment rate (%) of Romania?
Your answer should be compact. -2.15. In the year 1998, what is the difference between the Enrollment rate (%) in Upper middle income and Enrollment rate (%) in Bulgaria?
Make the answer very short. -5.38. In the year 1998, what is the difference between the Enrollment rate (%) of Upper middle income and Enrollment rate (%) of Romania?
Provide a succinct answer. 0.21. In the year 1998, what is the difference between the Enrollment rate (%) of Bulgaria and Enrollment rate (%) of Romania?
Provide a succinct answer. 5.6. In the year 1999, what is the difference between the Enrollment rate (%) of High income: nonOECD and Enrollment rate (%) of Upper middle income?
Your answer should be compact. -5.09. In the year 1999, what is the difference between the Enrollment rate (%) of High income: nonOECD and Enrollment rate (%) of Bulgaria?
Your answer should be compact. -8.6. In the year 1999, what is the difference between the Enrollment rate (%) of High income: nonOECD and Enrollment rate (%) of Romania?
Offer a very short reply. 0.66. In the year 1999, what is the difference between the Enrollment rate (%) in Upper middle income and Enrollment rate (%) in Bulgaria?
Keep it short and to the point. -3.5. In the year 1999, what is the difference between the Enrollment rate (%) in Upper middle income and Enrollment rate (%) in Romania?
Make the answer very short. 5.75. In the year 1999, what is the difference between the Enrollment rate (%) of Bulgaria and Enrollment rate (%) of Romania?
Ensure brevity in your answer.  9.25. In the year 2000, what is the difference between the Enrollment rate (%) in High income: nonOECD and Enrollment rate (%) in Upper middle income?
Make the answer very short. -4.22. In the year 2000, what is the difference between the Enrollment rate (%) of High income: nonOECD and Enrollment rate (%) of Bulgaria?
Offer a terse response. -7.19. In the year 2000, what is the difference between the Enrollment rate (%) of Upper middle income and Enrollment rate (%) of Bulgaria?
Provide a short and direct response. -2.97. In the year 2000, what is the difference between the Enrollment rate (%) in Upper middle income and Enrollment rate (%) in Romania?
Give a very brief answer. 5.21. In the year 2000, what is the difference between the Enrollment rate (%) in Bulgaria and Enrollment rate (%) in Romania?
Your response must be concise. 8.18. In the year 2001, what is the difference between the Enrollment rate (%) of High income: nonOECD and Enrollment rate (%) of Upper middle income?
Provide a short and direct response. -2.82. In the year 2001, what is the difference between the Enrollment rate (%) of High income: nonOECD and Enrollment rate (%) of Bulgaria?
Offer a terse response. -5.76. In the year 2001, what is the difference between the Enrollment rate (%) in High income: nonOECD and Enrollment rate (%) in Romania?
Provide a succinct answer. 0.7. In the year 2001, what is the difference between the Enrollment rate (%) in Upper middle income and Enrollment rate (%) in Bulgaria?
Provide a succinct answer. -2.95. In the year 2001, what is the difference between the Enrollment rate (%) in Upper middle income and Enrollment rate (%) in Romania?
Your response must be concise. 3.52. In the year 2001, what is the difference between the Enrollment rate (%) of Bulgaria and Enrollment rate (%) of Romania?
Your answer should be compact. 6.47. In the year 2002, what is the difference between the Enrollment rate (%) in High income: nonOECD and Enrollment rate (%) in Upper middle income?
Provide a succinct answer. -2.01. In the year 2002, what is the difference between the Enrollment rate (%) of High income: nonOECD and Enrollment rate (%) of Bulgaria?
Offer a terse response. -3.86. In the year 2002, what is the difference between the Enrollment rate (%) of High income: nonOECD and Enrollment rate (%) of Romania?
Offer a terse response. -2.57. In the year 2002, what is the difference between the Enrollment rate (%) in Upper middle income and Enrollment rate (%) in Bulgaria?
Ensure brevity in your answer.  -1.85. In the year 2002, what is the difference between the Enrollment rate (%) of Upper middle income and Enrollment rate (%) of Romania?
Offer a very short reply. -0.57. In the year 2002, what is the difference between the Enrollment rate (%) of Bulgaria and Enrollment rate (%) of Romania?
Make the answer very short. 1.28. In the year 2004, what is the difference between the Enrollment rate (%) in High income: nonOECD and Enrollment rate (%) in Upper middle income?
Your response must be concise. -2.28. In the year 2004, what is the difference between the Enrollment rate (%) of High income: nonOECD and Enrollment rate (%) of Bulgaria?
Offer a very short reply. -3.47. In the year 2004, what is the difference between the Enrollment rate (%) in High income: nonOECD and Enrollment rate (%) in Romania?
Keep it short and to the point. -5.38. In the year 2004, what is the difference between the Enrollment rate (%) of Upper middle income and Enrollment rate (%) of Bulgaria?
Make the answer very short. -1.19. In the year 2004, what is the difference between the Enrollment rate (%) in Upper middle income and Enrollment rate (%) in Romania?
Make the answer very short. -3.11. In the year 2004, what is the difference between the Enrollment rate (%) of Bulgaria and Enrollment rate (%) of Romania?
Ensure brevity in your answer.  -1.92. In the year 2005, what is the difference between the Enrollment rate (%) in High income: nonOECD and Enrollment rate (%) in Upper middle income?
Offer a very short reply. -4.25. In the year 2005, what is the difference between the Enrollment rate (%) in High income: nonOECD and Enrollment rate (%) in Bulgaria?
Provide a short and direct response. -2.76. In the year 2005, what is the difference between the Enrollment rate (%) in High income: nonOECD and Enrollment rate (%) in Romania?
Make the answer very short. -7.58. In the year 2005, what is the difference between the Enrollment rate (%) of Upper middle income and Enrollment rate (%) of Bulgaria?
Keep it short and to the point. 1.49. In the year 2005, what is the difference between the Enrollment rate (%) in Upper middle income and Enrollment rate (%) in Romania?
Your answer should be very brief. -3.34. In the year 2005, what is the difference between the Enrollment rate (%) of Bulgaria and Enrollment rate (%) of Romania?
Offer a very short reply. -4.83. What is the ratio of the Enrollment rate (%) of High income: nonOECD in 1997 to that in 1998?
Your answer should be compact. 1.01. What is the ratio of the Enrollment rate (%) of Upper middle income in 1997 to that in 1998?
Your answer should be very brief. 0.97. What is the ratio of the Enrollment rate (%) in Bulgaria in 1997 to that in 1998?
Give a very brief answer. 0.98. What is the ratio of the Enrollment rate (%) in Romania in 1997 to that in 1998?
Your answer should be compact. 0.97. What is the ratio of the Enrollment rate (%) of High income: nonOECD in 1997 to that in 1999?
Provide a succinct answer. 1.01. What is the ratio of the Enrollment rate (%) in Upper middle income in 1997 to that in 1999?
Give a very brief answer. 0.94. What is the ratio of the Enrollment rate (%) in Bulgaria in 1997 to that in 1999?
Offer a terse response. 0.97. What is the ratio of the Enrollment rate (%) of Romania in 1997 to that in 1999?
Provide a short and direct response. 1. What is the ratio of the Enrollment rate (%) in High income: nonOECD in 1997 to that in 2000?
Provide a short and direct response. 0.99. What is the ratio of the Enrollment rate (%) in Upper middle income in 1997 to that in 2000?
Provide a short and direct response. 0.93. What is the ratio of the Enrollment rate (%) of Bulgaria in 1997 to that in 2000?
Your answer should be compact. 0.97. What is the ratio of the Enrollment rate (%) of Romania in 1997 to that in 2000?
Offer a terse response. 0.99. What is the ratio of the Enrollment rate (%) of High income: nonOECD in 1997 to that in 2001?
Give a very brief answer. 0.97. What is the ratio of the Enrollment rate (%) in Upper middle income in 1997 to that in 2001?
Your answer should be very brief. 0.93. What is the ratio of the Enrollment rate (%) of Bulgaria in 1997 to that in 2001?
Make the answer very short. 0.97. What is the ratio of the Enrollment rate (%) of Romania in 1997 to that in 2001?
Your response must be concise. 0.97. What is the ratio of the Enrollment rate (%) in High income: nonOECD in 1997 to that in 2002?
Offer a terse response. 0.96. What is the ratio of the Enrollment rate (%) of Upper middle income in 1997 to that in 2002?
Give a very brief answer. 0.92. What is the ratio of the Enrollment rate (%) of Bulgaria in 1997 to that in 2002?
Offer a very short reply. 0.97. What is the ratio of the Enrollment rate (%) in Romania in 1997 to that in 2002?
Your answer should be compact. 0.92. What is the ratio of the Enrollment rate (%) in High income: nonOECD in 1997 to that in 2004?
Offer a terse response. 0.96. What is the ratio of the Enrollment rate (%) of Upper middle income in 1997 to that in 2004?
Provide a short and direct response. 0.92. What is the ratio of the Enrollment rate (%) of Bulgaria in 1997 to that in 2004?
Your answer should be very brief. 0.98. What is the ratio of the Enrollment rate (%) in Romania in 1997 to that in 2004?
Offer a very short reply. 0.89. What is the ratio of the Enrollment rate (%) in High income: nonOECD in 1997 to that in 2005?
Keep it short and to the point. 0.98. What is the ratio of the Enrollment rate (%) in Upper middle income in 1997 to that in 2005?
Provide a succinct answer. 0.92. What is the ratio of the Enrollment rate (%) in Romania in 1997 to that in 2005?
Your answer should be compact. 0.89. What is the ratio of the Enrollment rate (%) of Upper middle income in 1998 to that in 1999?
Provide a short and direct response. 0.97. What is the ratio of the Enrollment rate (%) in Bulgaria in 1998 to that in 1999?
Offer a very short reply. 0.99. What is the ratio of the Enrollment rate (%) of Romania in 1998 to that in 1999?
Make the answer very short. 1.03. What is the ratio of the Enrollment rate (%) in High income: nonOECD in 1998 to that in 2000?
Offer a terse response. 0.99. What is the ratio of the Enrollment rate (%) in Upper middle income in 1998 to that in 2000?
Offer a terse response. 0.97. What is the ratio of the Enrollment rate (%) of Bulgaria in 1998 to that in 2000?
Your answer should be very brief. 0.99. What is the ratio of the Enrollment rate (%) in Romania in 1998 to that in 2000?
Your answer should be compact. 1.02. What is the ratio of the Enrollment rate (%) of High income: nonOECD in 1998 to that in 2001?
Provide a succinct answer. 0.97. What is the ratio of the Enrollment rate (%) of Upper middle income in 1998 to that in 2001?
Provide a succinct answer. 0.96. What is the ratio of the Enrollment rate (%) in High income: nonOECD in 1998 to that in 2002?
Offer a very short reply. 0.95. What is the ratio of the Enrollment rate (%) of Upper middle income in 1998 to that in 2002?
Keep it short and to the point. 0.96. What is the ratio of the Enrollment rate (%) in Romania in 1998 to that in 2002?
Offer a terse response. 0.95. What is the ratio of the Enrollment rate (%) in High income: nonOECD in 1998 to that in 2004?
Ensure brevity in your answer.  0.95. What is the ratio of the Enrollment rate (%) of Upper middle income in 1998 to that in 2004?
Your answer should be very brief. 0.95. What is the ratio of the Enrollment rate (%) of Bulgaria in 1998 to that in 2004?
Give a very brief answer. 1. What is the ratio of the Enrollment rate (%) in Romania in 1998 to that in 2004?
Provide a succinct answer. 0.92. What is the ratio of the Enrollment rate (%) of High income: nonOECD in 1998 to that in 2005?
Your answer should be very brief. 0.97. What is the ratio of the Enrollment rate (%) in Upper middle income in 1998 to that in 2005?
Your answer should be very brief. 0.96. What is the ratio of the Enrollment rate (%) in Bulgaria in 1998 to that in 2005?
Keep it short and to the point. 1.03. What is the ratio of the Enrollment rate (%) in Romania in 1998 to that in 2005?
Your response must be concise. 0.92. What is the ratio of the Enrollment rate (%) in High income: nonOECD in 1999 to that in 2000?
Provide a short and direct response. 0.99. What is the ratio of the Enrollment rate (%) in Upper middle income in 1999 to that in 2000?
Provide a succinct answer. 1. What is the ratio of the Enrollment rate (%) of Romania in 1999 to that in 2000?
Make the answer very short. 0.99. What is the ratio of the Enrollment rate (%) of High income: nonOECD in 1999 to that in 2001?
Offer a very short reply. 0.97. What is the ratio of the Enrollment rate (%) in Bulgaria in 1999 to that in 2001?
Your answer should be compact. 1. What is the ratio of the Enrollment rate (%) in Romania in 1999 to that in 2001?
Offer a terse response. 0.97. What is the ratio of the Enrollment rate (%) in High income: nonOECD in 1999 to that in 2002?
Ensure brevity in your answer.  0.95. What is the ratio of the Enrollment rate (%) in Upper middle income in 1999 to that in 2002?
Keep it short and to the point. 0.98. What is the ratio of the Enrollment rate (%) in Romania in 1999 to that in 2002?
Make the answer very short. 0.92. What is the ratio of the Enrollment rate (%) in High income: nonOECD in 1999 to that in 2004?
Offer a very short reply. 0.95. What is the ratio of the Enrollment rate (%) in Upper middle income in 1999 to that in 2004?
Ensure brevity in your answer.  0.98. What is the ratio of the Enrollment rate (%) of Romania in 1999 to that in 2004?
Give a very brief answer. 0.89. What is the ratio of the Enrollment rate (%) in High income: nonOECD in 1999 to that in 2005?
Keep it short and to the point. 0.97. What is the ratio of the Enrollment rate (%) in Upper middle income in 1999 to that in 2005?
Your answer should be compact. 0.98. What is the ratio of the Enrollment rate (%) of Bulgaria in 1999 to that in 2005?
Your answer should be compact. 1.04. What is the ratio of the Enrollment rate (%) of Romania in 1999 to that in 2005?
Your answer should be compact. 0.89. What is the ratio of the Enrollment rate (%) of High income: nonOECD in 2000 to that in 2001?
Your answer should be compact. 0.98. What is the ratio of the Enrollment rate (%) in Romania in 2000 to that in 2001?
Give a very brief answer. 0.98. What is the ratio of the Enrollment rate (%) in High income: nonOECD in 2000 to that in 2002?
Offer a very short reply. 0.96. What is the ratio of the Enrollment rate (%) in Upper middle income in 2000 to that in 2002?
Give a very brief answer. 0.99. What is the ratio of the Enrollment rate (%) in Bulgaria in 2000 to that in 2002?
Ensure brevity in your answer.  1. What is the ratio of the Enrollment rate (%) of Romania in 2000 to that in 2002?
Your answer should be very brief. 0.93. What is the ratio of the Enrollment rate (%) of High income: nonOECD in 2000 to that in 2004?
Make the answer very short. 0.96. What is the ratio of the Enrollment rate (%) in Upper middle income in 2000 to that in 2004?
Your response must be concise. 0.98. What is the ratio of the Enrollment rate (%) in Romania in 2000 to that in 2004?
Your answer should be very brief. 0.9. What is the ratio of the Enrollment rate (%) of Upper middle income in 2000 to that in 2005?
Your answer should be compact. 0.99. What is the ratio of the Enrollment rate (%) in Bulgaria in 2000 to that in 2005?
Your response must be concise. 1.04. What is the ratio of the Enrollment rate (%) of Romania in 2000 to that in 2005?
Keep it short and to the point. 0.9. What is the ratio of the Enrollment rate (%) in High income: nonOECD in 2001 to that in 2002?
Ensure brevity in your answer.  0.98. What is the ratio of the Enrollment rate (%) in Bulgaria in 2001 to that in 2002?
Provide a succinct answer. 1. What is the ratio of the Enrollment rate (%) of Romania in 2001 to that in 2002?
Provide a succinct answer. 0.95. What is the ratio of the Enrollment rate (%) of High income: nonOECD in 2001 to that in 2004?
Keep it short and to the point. 0.98. What is the ratio of the Enrollment rate (%) of Upper middle income in 2001 to that in 2004?
Give a very brief answer. 0.99. What is the ratio of the Enrollment rate (%) in Bulgaria in 2001 to that in 2004?
Your response must be concise. 1.01. What is the ratio of the Enrollment rate (%) in Romania in 2001 to that in 2004?
Provide a short and direct response. 0.92. What is the ratio of the Enrollment rate (%) of High income: nonOECD in 2001 to that in 2005?
Your response must be concise. 1.01. What is the ratio of the Enrollment rate (%) of Upper middle income in 2001 to that in 2005?
Your answer should be very brief. 0.99. What is the ratio of the Enrollment rate (%) of Bulgaria in 2001 to that in 2005?
Ensure brevity in your answer.  1.04. What is the ratio of the Enrollment rate (%) of Romania in 2001 to that in 2005?
Your answer should be compact. 0.92. What is the ratio of the Enrollment rate (%) of Upper middle income in 2002 to that in 2004?
Your response must be concise. 1. What is the ratio of the Enrollment rate (%) of Romania in 2002 to that in 2004?
Give a very brief answer. 0.97. What is the ratio of the Enrollment rate (%) in High income: nonOECD in 2002 to that in 2005?
Keep it short and to the point. 1.02. What is the ratio of the Enrollment rate (%) in Bulgaria in 2002 to that in 2005?
Offer a very short reply. 1.04. What is the ratio of the Enrollment rate (%) in Romania in 2002 to that in 2005?
Provide a succinct answer. 0.97. What is the ratio of the Enrollment rate (%) in High income: nonOECD in 2004 to that in 2005?
Offer a very short reply. 1.03. What is the ratio of the Enrollment rate (%) of Bulgaria in 2004 to that in 2005?
Make the answer very short. 1.03. What is the difference between the highest and the second highest Enrollment rate (%) in High income: nonOECD?
Make the answer very short. 0.08. What is the difference between the highest and the second highest Enrollment rate (%) in Upper middle income?
Make the answer very short. 0.35. What is the difference between the highest and the second highest Enrollment rate (%) of Bulgaria?
Provide a short and direct response. 0.25. What is the difference between the highest and the second highest Enrollment rate (%) in Romania?
Your answer should be very brief. 0.12. What is the difference between the highest and the lowest Enrollment rate (%) in High income: nonOECD?
Ensure brevity in your answer.  4.71. What is the difference between the highest and the lowest Enrollment rate (%) of Upper middle income?
Provide a short and direct response. 7.69. What is the difference between the highest and the lowest Enrollment rate (%) of Bulgaria?
Ensure brevity in your answer.  3.77. What is the difference between the highest and the lowest Enrollment rate (%) of Romania?
Offer a very short reply. 10.68. 